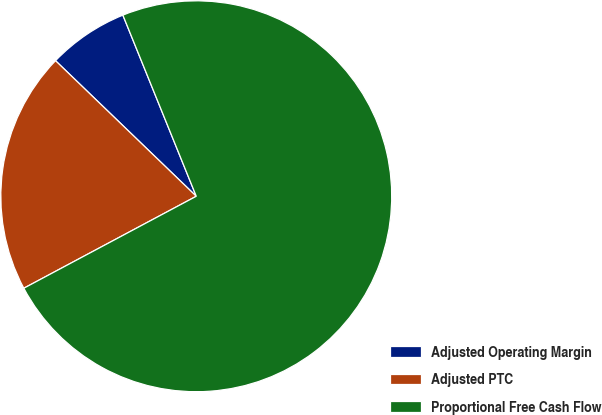<chart> <loc_0><loc_0><loc_500><loc_500><pie_chart><fcel>Adjusted Operating Margin<fcel>Adjusted PTC<fcel>Proportional Free Cash Flow<nl><fcel>6.67%<fcel>20.0%<fcel>73.33%<nl></chart> 